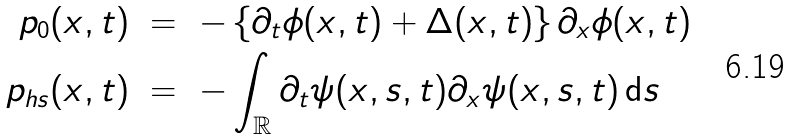<formula> <loc_0><loc_0><loc_500><loc_500>p _ { 0 } ( x , t ) \ & = \ - \left \{ \partial _ { t } \phi ( x , t ) + \Delta ( x , t ) \right \} \partial _ { x } \phi ( x , t ) \\ p _ { h s } ( x , t ) \ & = \ - \int _ { \mathbb { R } } \partial _ { t } \psi ( x , s , t ) \partial _ { x } \psi ( x , s , t ) \, \mathrm d s</formula> 